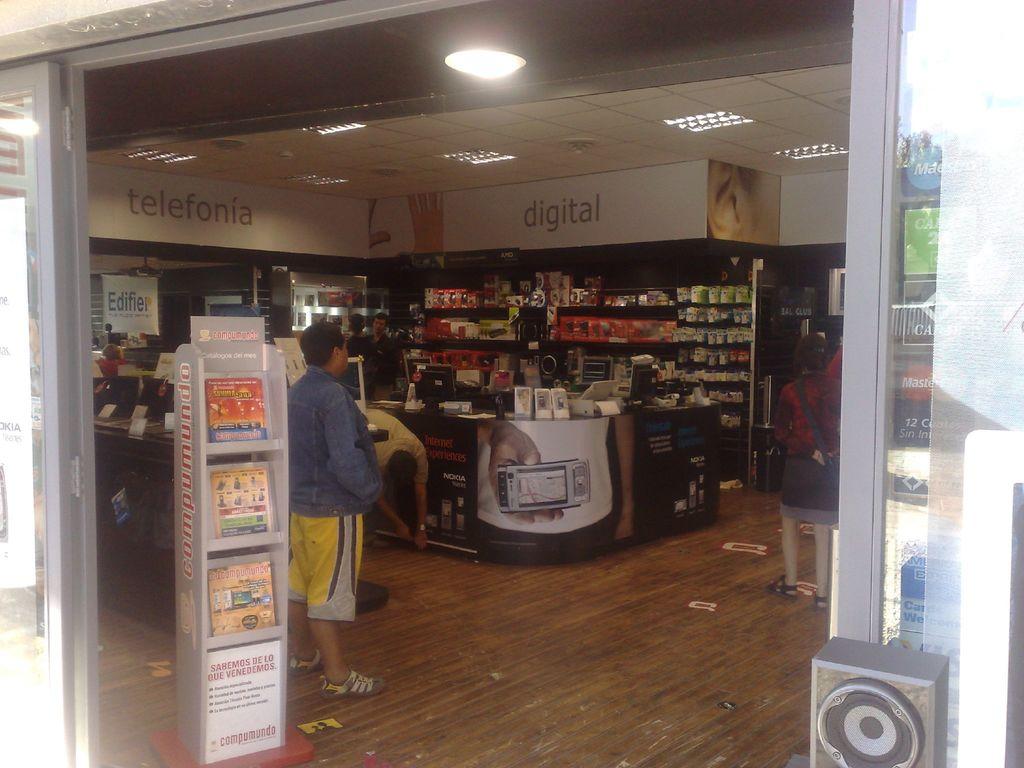What part of the store is in this?
Make the answer very short. Digital. Do they sell telephones?
Your answer should be very brief. Yes. 